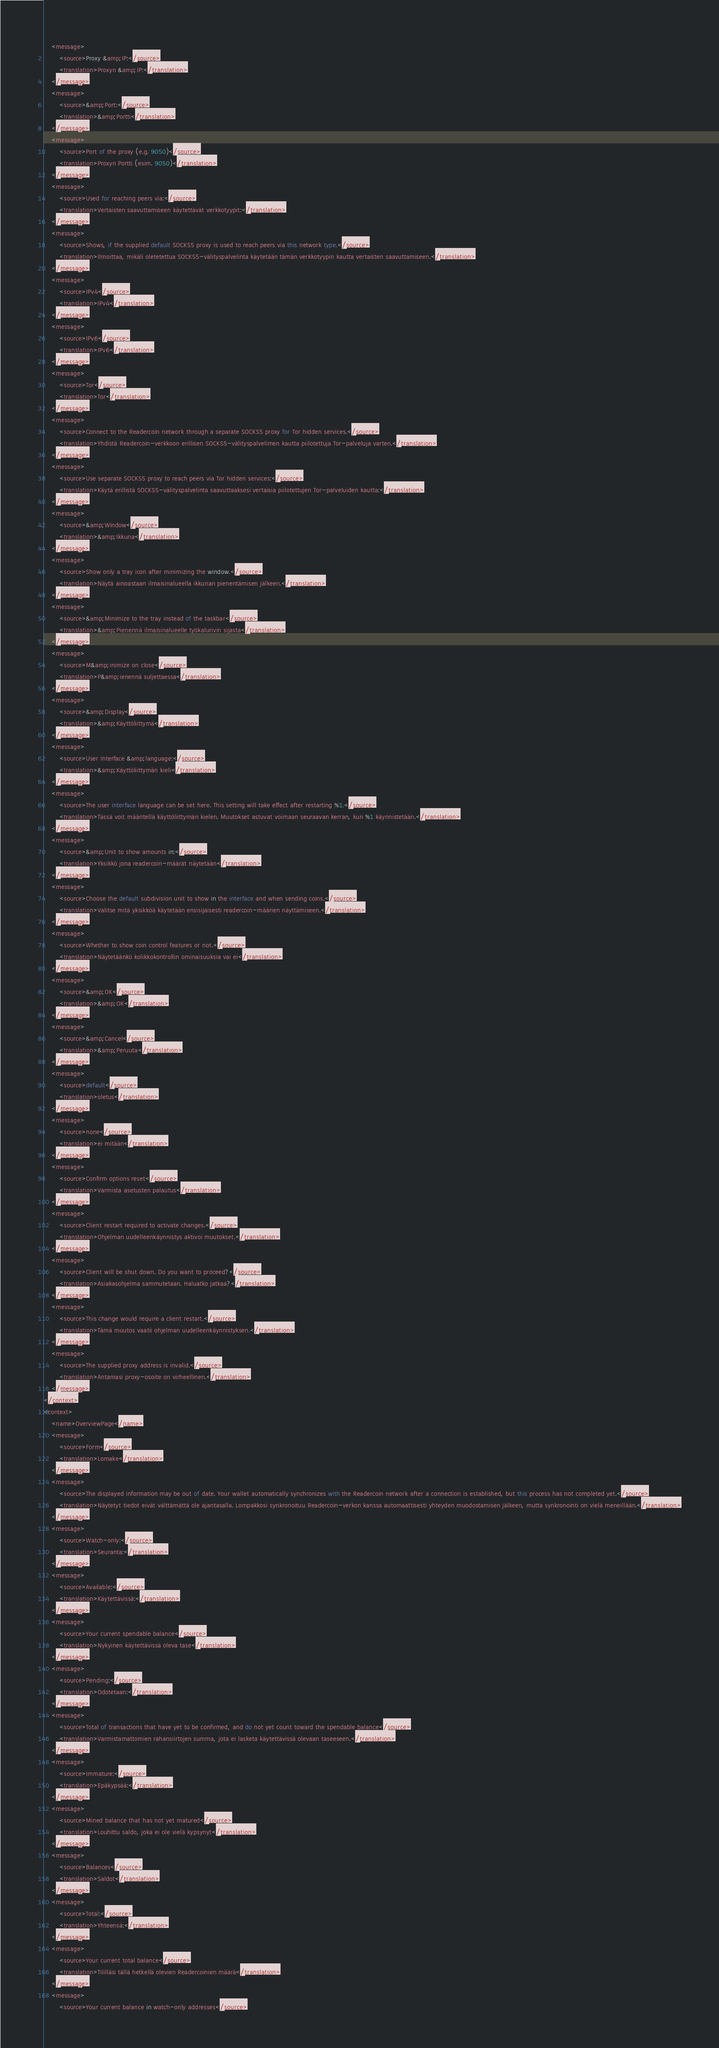Convert code to text. <code><loc_0><loc_0><loc_500><loc_500><_TypeScript_>    <message>
        <source>Proxy &amp;IP:</source>
        <translation>Proxyn &amp;IP:</translation>
    </message>
    <message>
        <source>&amp;Port:</source>
        <translation>&amp;Portti</translation>
    </message>
    <message>
        <source>Port of the proxy (e.g. 9050)</source>
        <translation>Proxyn Portti (esim. 9050)</translation>
    </message>
    <message>
        <source>Used for reaching peers via:</source>
        <translation>Vertaisten saavuttamiseen käytettävät verkkotyypit:</translation>
    </message>
    <message>
        <source>Shows, if the supplied default SOCKS5 proxy is used to reach peers via this network type.</source>
        <translation>Ilmoittaa, mikäli oletetettua SOCKS5-välityspalvelinta käytetään tämän verkkotyypin kautta vertaisten saavuttamiseen.</translation>
    </message>
    <message>
        <source>IPv4</source>
        <translation>IPv4</translation>
    </message>
    <message>
        <source>IPv6</source>
        <translation>IPv6</translation>
    </message>
    <message>
        <source>Tor</source>
        <translation>Tor</translation>
    </message>
    <message>
        <source>Connect to the Readercoin network through a separate SOCKS5 proxy for Tor hidden services.</source>
        <translation>Yhdistä Readercoin-verkkoon erillisen SOCKS5-välityspalvelimen kautta piilotettuja Tor-palveluja varten.</translation>
    </message>
    <message>
        <source>Use separate SOCKS5 proxy to reach peers via Tor hidden services:</source>
        <translation>Käytä erillistä SOCKS5-välityspalvelinta saavuttaaksesi vertaisia piilotettujen Tor-palveluiden kautta:</translation>
    </message>
    <message>
        <source>&amp;Window</source>
        <translation>&amp;Ikkuna</translation>
    </message>
    <message>
        <source>Show only a tray icon after minimizing the window.</source>
        <translation>Näytä ainoastaan ilmaisinalueella ikkunan pienentämisen jälkeen.</translation>
    </message>
    <message>
        <source>&amp;Minimize to the tray instead of the taskbar</source>
        <translation>&amp;Pienennä ilmaisinalueelle työkalurivin sijasta</translation>
    </message>
    <message>
        <source>M&amp;inimize on close</source>
        <translation>P&amp;ienennä suljettaessa</translation>
    </message>
    <message>
        <source>&amp;Display</source>
        <translation>&amp;Käyttöliittymä</translation>
    </message>
    <message>
        <source>User Interface &amp;language:</source>
        <translation>&amp;Käyttöliittymän kieli</translation>
    </message>
    <message>
        <source>The user interface language can be set here. This setting will take effect after restarting %1.</source>
        <translation>Tässä voit määritellä käyttöliittymän kielen. Muutokset astuvat voimaan seuraavan kerran, kun %1 käynnistetään.</translation>
    </message>
    <message>
        <source>&amp;Unit to show amounts in:</source>
        <translation>Yksikkö jona readercoin-määrät näytetään</translation>
    </message>
    <message>
        <source>Choose the default subdivision unit to show in the interface and when sending coins.</source>
        <translation>Valitse mitä yksikköä käytetään ensisijaisesti readercoin-määrien näyttämiseen.</translation>
    </message>
    <message>
        <source>Whether to show coin control features or not.</source>
        <translation>Näytetäänkö kolikkokontrollin ominaisuuksia vai ei</translation>
    </message>
    <message>
        <source>&amp;OK</source>
        <translation>&amp;OK</translation>
    </message>
    <message>
        <source>&amp;Cancel</source>
        <translation>&amp;Peruuta</translation>
    </message>
    <message>
        <source>default</source>
        <translation>oletus</translation>
    </message>
    <message>
        <source>none</source>
        <translation>ei mitään</translation>
    </message>
    <message>
        <source>Confirm options reset</source>
        <translation>Varmista asetusten palautus</translation>
    </message>
    <message>
        <source>Client restart required to activate changes.</source>
        <translation>Ohjelman uudelleenkäynnistys aktivoi muutokset.</translation>
    </message>
    <message>
        <source>Client will be shut down. Do you want to proceed?</source>
        <translation>Asiakasohjelma sammutetaan. Haluatko jatkaa?</translation>
    </message>
    <message>
        <source>This change would require a client restart.</source>
        <translation>Tämä muutos vaatii ohjelman uudelleenkäynnistyksen.</translation>
    </message>
    <message>
        <source>The supplied proxy address is invalid.</source>
        <translation>Antamasi proxy-osoite on virheellinen.</translation>
    </message>
</context>
<context>
    <name>OverviewPage</name>
    <message>
        <source>Form</source>
        <translation>Lomake</translation>
    </message>
    <message>
        <source>The displayed information may be out of date. Your wallet automatically synchronizes with the Readercoin network after a connection is established, but this process has not completed yet.</source>
        <translation>Näytetyt tiedot eivät välttämättä ole ajantasalla. Lompakkosi synkronoituu Readercoin-verkon kanssa automaattisesti yhteyden muodostamisen jälkeen, mutta synkronointi on vielä meneillään.</translation>
    </message>
    <message>
        <source>Watch-only:</source>
        <translation>Seuranta:</translation>
    </message>
    <message>
        <source>Available:</source>
        <translation>Käytettävissä:</translation>
    </message>
    <message>
        <source>Your current spendable balance</source>
        <translation>Nykyinen käytettävissä oleva tase</translation>
    </message>
    <message>
        <source>Pending:</source>
        <translation>Odotetaan:</translation>
    </message>
    <message>
        <source>Total of transactions that have yet to be confirmed, and do not yet count toward the spendable balance</source>
        <translation>Varmistamattomien rahansiirtojen summa, jota ei lasketa käytettävissä olevaan taseeseen.</translation>
    </message>
    <message>
        <source>Immature:</source>
        <translation>Epäkypsää:</translation>
    </message>
    <message>
        <source>Mined balance that has not yet matured</source>
        <translation>Louhittu saldo, joka ei ole vielä kypsynyt</translation>
    </message>
    <message>
        <source>Balances</source>
        <translation>Saldot</translation>
    </message>
    <message>
        <source>Total:</source>
        <translation>Yhteensä:</translation>
    </message>
    <message>
        <source>Your current total balance</source>
        <translation>Tililläsi tällä hetkellä olevien Readercoinien määrä</translation>
    </message>
    <message>
        <source>Your current balance in watch-only addresses</source></code> 